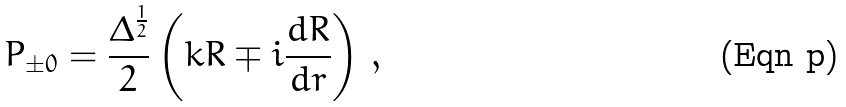Convert formula to latex. <formula><loc_0><loc_0><loc_500><loc_500>P _ { \pm 0 } = \frac { \Delta ^ { \frac { 1 } { 2 } } } { 2 } \left ( k R \mp i \frac { d R } { d r } \right ) \, ,</formula> 